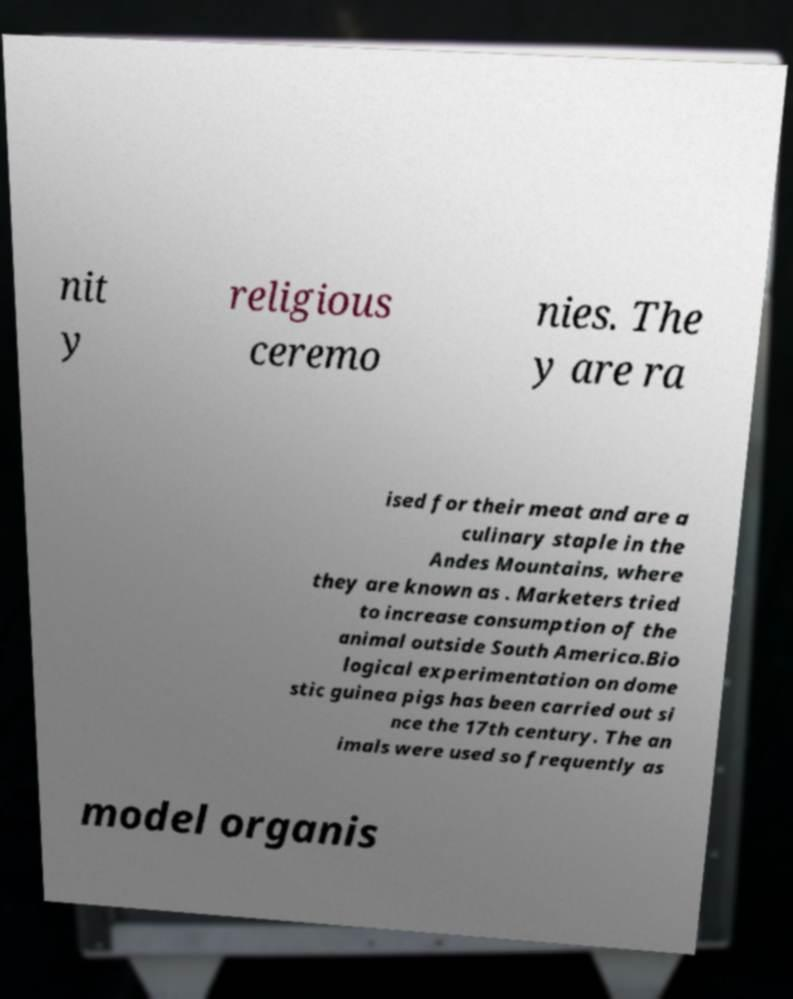Can you read and provide the text displayed in the image?This photo seems to have some interesting text. Can you extract and type it out for me? nit y religious ceremo nies. The y are ra ised for their meat and are a culinary staple in the Andes Mountains, where they are known as . Marketers tried to increase consumption of the animal outside South America.Bio logical experimentation on dome stic guinea pigs has been carried out si nce the 17th century. The an imals were used so frequently as model organis 